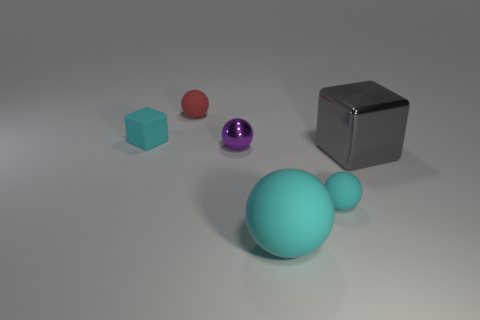How many other objects are the same shape as the large cyan rubber object? In the image, the large cyan rubber object appears to be of a spherical shape. Upon closer inspection, there are two other objects sharing this characteristic—a small red sphere and a medium purple sphere. Therefore, including the large cyan sphere, there are a total of three spherical objects in this scene. 